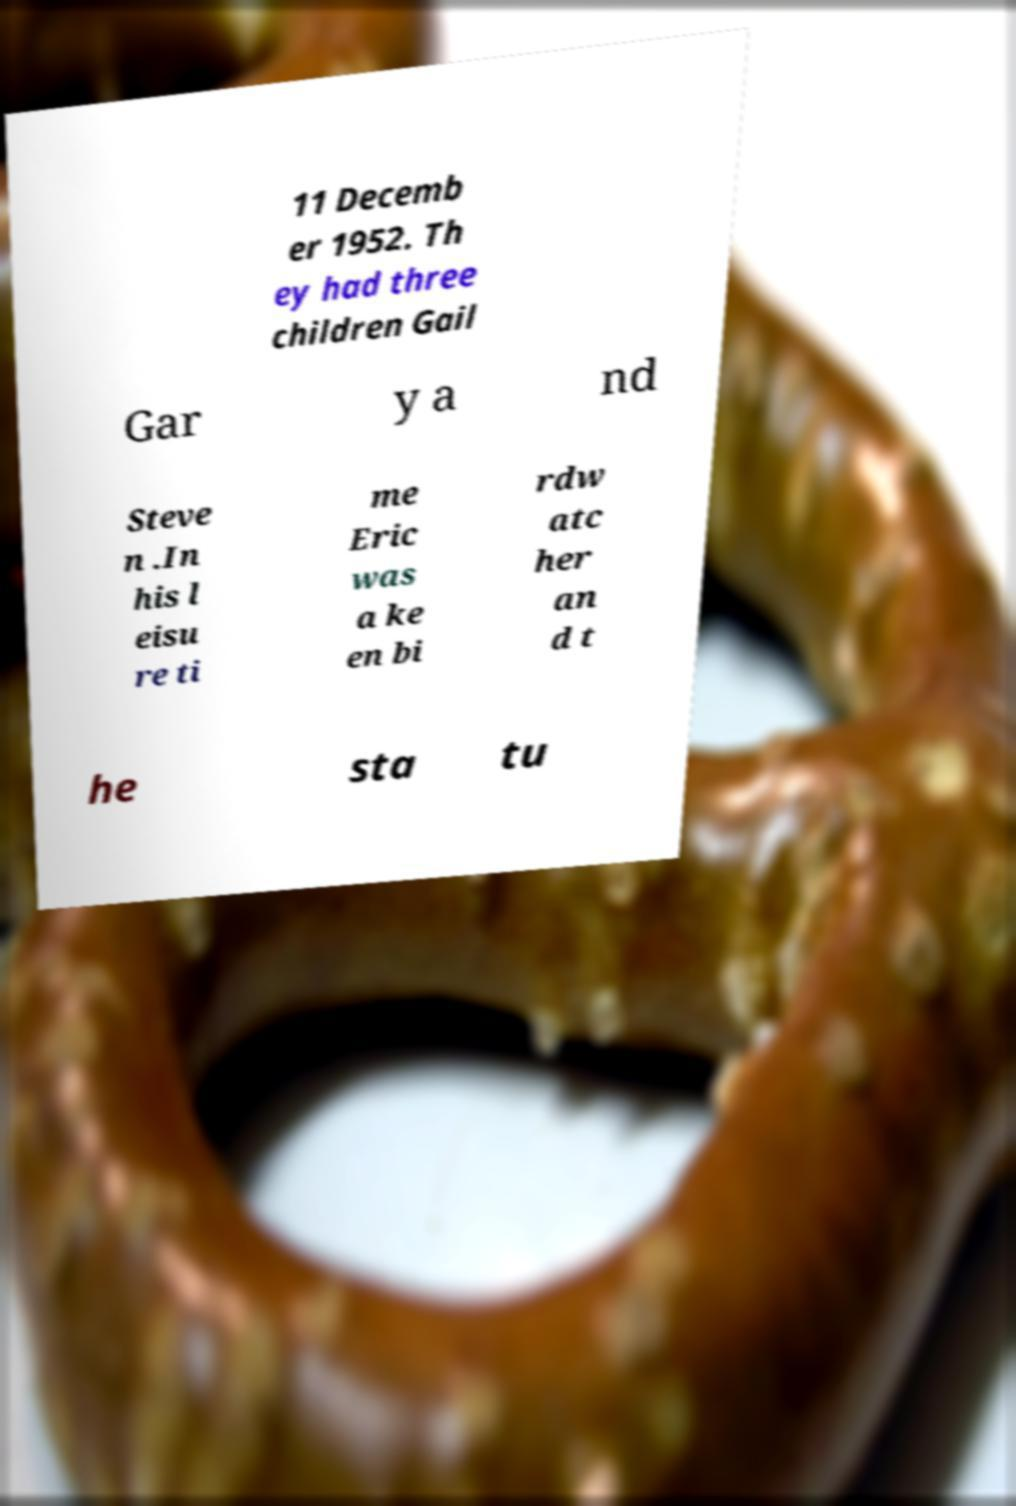Could you extract and type out the text from this image? 11 Decemb er 1952. Th ey had three children Gail Gar y a nd Steve n .In his l eisu re ti me Eric was a ke en bi rdw atc her an d t he sta tu 